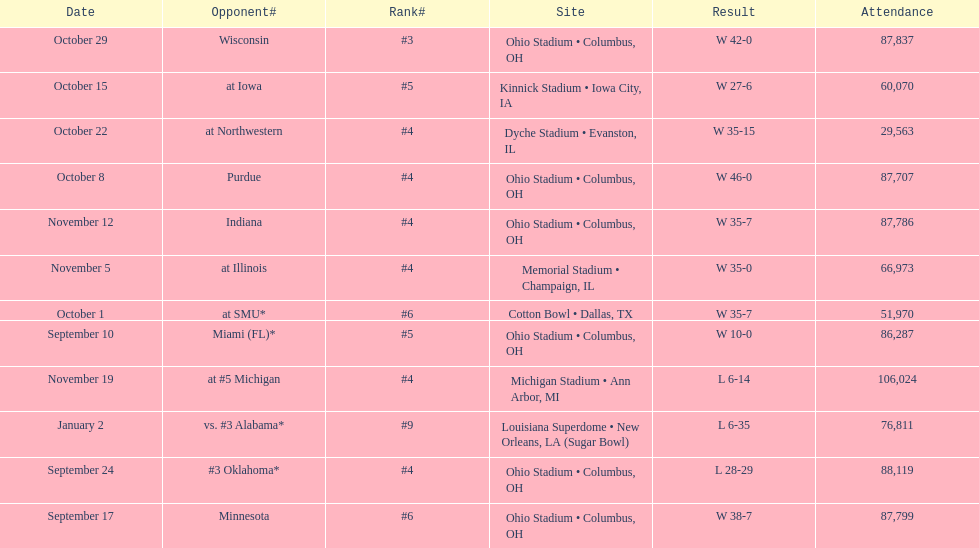What was the last game to be attended by fewer than 30,000 people? October 22. 